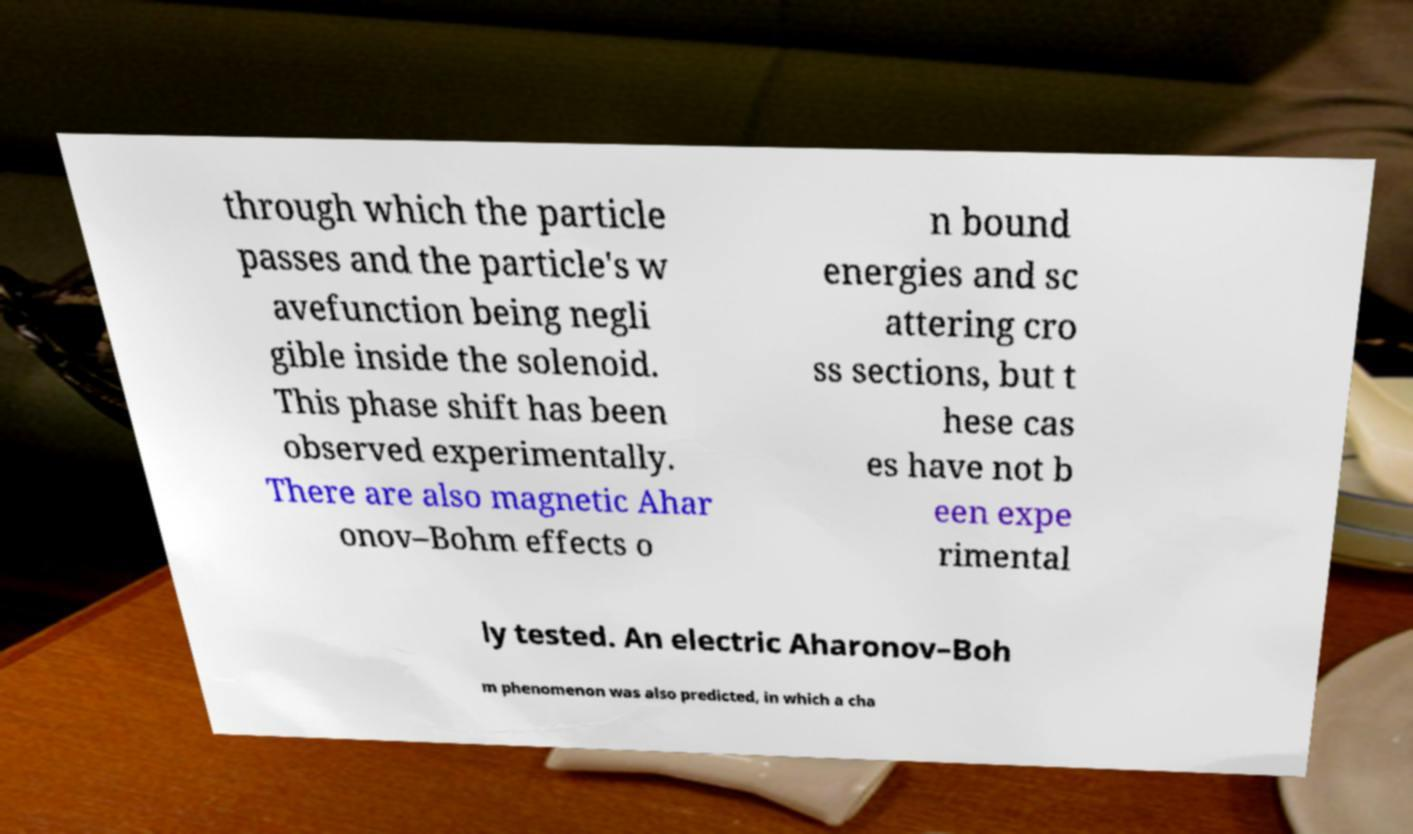Please read and relay the text visible in this image. What does it say? through which the particle passes and the particle's w avefunction being negli gible inside the solenoid. This phase shift has been observed experimentally. There are also magnetic Ahar onov–Bohm effects o n bound energies and sc attering cro ss sections, but t hese cas es have not b een expe rimental ly tested. An electric Aharonov–Boh m phenomenon was also predicted, in which a cha 